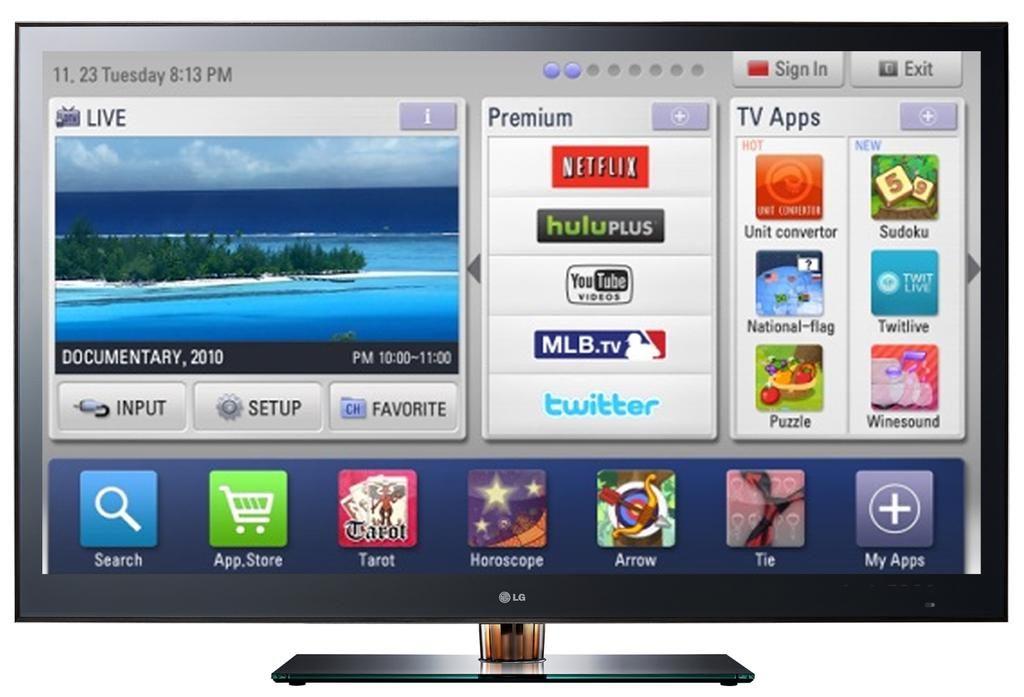What type of device is visible in the image? There is a monitor in the image. How is the monitor positioned in the image? The monitor has a stand. What can be seen on the monitor's screen? The screen displays an image, text, icons, and applications. Can you describe the rhythm of the swing in the image? There is no swing present in the image; it features a monitor with a stand and a screen displaying various content. 